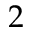<formula> <loc_0><loc_0><loc_500><loc_500>2</formula> 